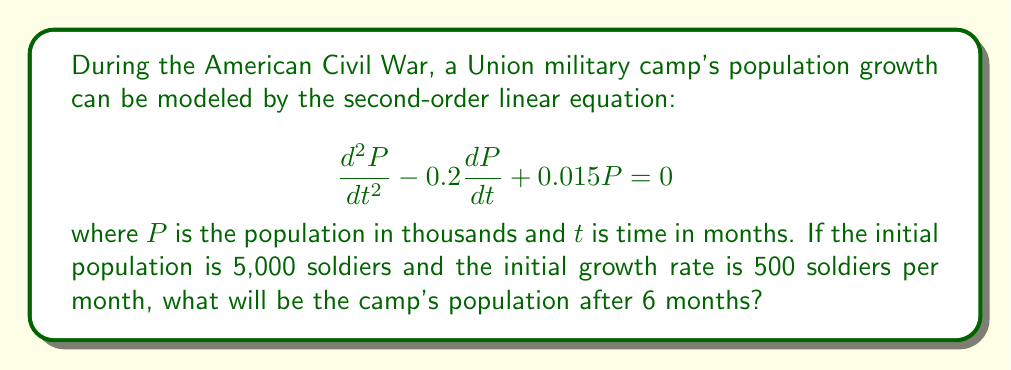Show me your answer to this math problem. To solve this problem, we need to follow these steps:

1) First, we need to find the general solution to the differential equation. The characteristic equation is:

   $$r^2 - 0.2r + 0.015 = 0$$

2) Solving this quadratic equation:
   
   $$r = \frac{0.2 \pm \sqrt{0.04 - 0.06}}{2} = \frac{0.2 \pm \sqrt{-0.02}}{2} = 0.1 \pm 0.1i$$

3) Therefore, the general solution is:

   $$P(t) = e^{0.1t}(C_1\cos(0.1t) + C_2\sin(0.1t))$$

4) Now we use the initial conditions to find $C_1$ and $C_2$:
   
   $P(0) = 5$ gives us: $C_1 = 5$

   $P'(0) = 0.5$ gives us: $0.1C_1 + 0.1C_2 = 0.5$
   
   Substituting $C_1 = 5$: $0.5 + 0.1C_2 = 0.5$, so $C_2 = 0$

5) Therefore, the particular solution is:

   $$P(t) = 5e^{0.1t}\cos(0.1t)$$

6) To find the population after 6 months, we substitute $t = 6$:

   $$P(6) = 5e^{0.1(6)}\cos(0.1(6)) = 5e^{0.6}\cos(0.6)$$

7) Calculating this:

   $$P(6) \approx 8.226$$

8) Since $P$ is in thousands, we multiply by 1000 to get the actual population.
Answer: The camp's population after 6 months will be approximately 8,226 soldiers. 